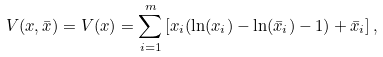Convert formula to latex. <formula><loc_0><loc_0><loc_500><loc_500>V ( x , \bar { x } ) = V ( x ) = \sum _ { i = 1 } ^ { m } \left [ x _ { i } ( \ln ( x _ { i } ) - \ln ( \bar { x } _ { i } ) - 1 ) + \bar { x } _ { i } \right ] ,</formula> 